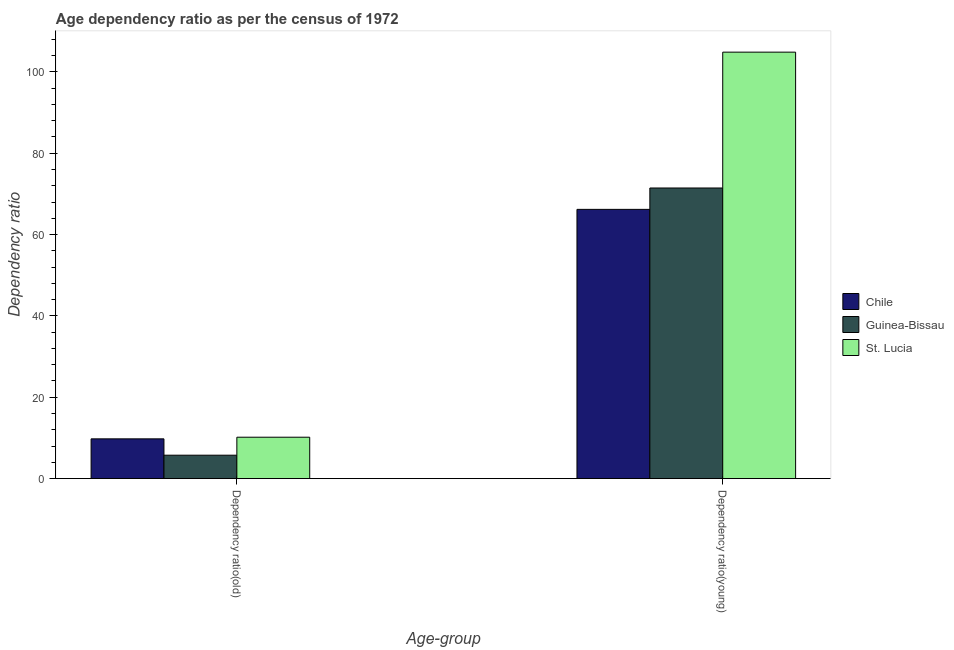How many different coloured bars are there?
Give a very brief answer. 3. How many bars are there on the 1st tick from the right?
Keep it short and to the point. 3. What is the label of the 1st group of bars from the left?
Ensure brevity in your answer.  Dependency ratio(old). What is the age dependency ratio(young) in Chile?
Provide a succinct answer. 66.2. Across all countries, what is the maximum age dependency ratio(old)?
Offer a terse response. 10.18. Across all countries, what is the minimum age dependency ratio(young)?
Provide a succinct answer. 66.2. In which country was the age dependency ratio(old) maximum?
Your response must be concise. St. Lucia. What is the total age dependency ratio(young) in the graph?
Give a very brief answer. 242.5. What is the difference between the age dependency ratio(old) in Chile and that in Guinea-Bissau?
Your answer should be compact. 4.02. What is the difference between the age dependency ratio(old) in Guinea-Bissau and the age dependency ratio(young) in St. Lucia?
Ensure brevity in your answer.  -99.1. What is the average age dependency ratio(young) per country?
Your answer should be very brief. 80.83. What is the difference between the age dependency ratio(young) and age dependency ratio(old) in Guinea-Bissau?
Provide a short and direct response. 65.7. In how many countries, is the age dependency ratio(young) greater than 68 ?
Offer a very short reply. 2. What is the ratio of the age dependency ratio(old) in St. Lucia to that in Chile?
Your response must be concise. 1.04. In how many countries, is the age dependency ratio(young) greater than the average age dependency ratio(young) taken over all countries?
Give a very brief answer. 1. What does the 3rd bar from the left in Dependency ratio(old) represents?
Make the answer very short. St. Lucia. What does the 2nd bar from the right in Dependency ratio(young) represents?
Provide a succinct answer. Guinea-Bissau. Are all the bars in the graph horizontal?
Give a very brief answer. No. What is the difference between two consecutive major ticks on the Y-axis?
Ensure brevity in your answer.  20. Are the values on the major ticks of Y-axis written in scientific E-notation?
Provide a succinct answer. No. Does the graph contain any zero values?
Ensure brevity in your answer.  No. Does the graph contain grids?
Offer a terse response. No. What is the title of the graph?
Your response must be concise. Age dependency ratio as per the census of 1972. Does "Liechtenstein" appear as one of the legend labels in the graph?
Your answer should be compact. No. What is the label or title of the X-axis?
Provide a short and direct response. Age-group. What is the label or title of the Y-axis?
Your answer should be very brief. Dependency ratio. What is the Dependency ratio in Chile in Dependency ratio(old)?
Your response must be concise. 9.78. What is the Dependency ratio in Guinea-Bissau in Dependency ratio(old)?
Keep it short and to the point. 5.76. What is the Dependency ratio in St. Lucia in Dependency ratio(old)?
Offer a terse response. 10.18. What is the Dependency ratio of Chile in Dependency ratio(young)?
Ensure brevity in your answer.  66.2. What is the Dependency ratio in Guinea-Bissau in Dependency ratio(young)?
Give a very brief answer. 71.45. What is the Dependency ratio of St. Lucia in Dependency ratio(young)?
Give a very brief answer. 104.85. Across all Age-group, what is the maximum Dependency ratio of Chile?
Your response must be concise. 66.2. Across all Age-group, what is the maximum Dependency ratio in Guinea-Bissau?
Offer a very short reply. 71.45. Across all Age-group, what is the maximum Dependency ratio in St. Lucia?
Give a very brief answer. 104.85. Across all Age-group, what is the minimum Dependency ratio in Chile?
Provide a short and direct response. 9.78. Across all Age-group, what is the minimum Dependency ratio of Guinea-Bissau?
Make the answer very short. 5.76. Across all Age-group, what is the minimum Dependency ratio of St. Lucia?
Provide a short and direct response. 10.18. What is the total Dependency ratio of Chile in the graph?
Your answer should be compact. 75.97. What is the total Dependency ratio in Guinea-Bissau in the graph?
Your answer should be compact. 77.21. What is the total Dependency ratio of St. Lucia in the graph?
Your response must be concise. 115.03. What is the difference between the Dependency ratio of Chile in Dependency ratio(old) and that in Dependency ratio(young)?
Offer a very short reply. -56.42. What is the difference between the Dependency ratio in Guinea-Bissau in Dependency ratio(old) and that in Dependency ratio(young)?
Your answer should be very brief. -65.7. What is the difference between the Dependency ratio of St. Lucia in Dependency ratio(old) and that in Dependency ratio(young)?
Provide a short and direct response. -94.67. What is the difference between the Dependency ratio in Chile in Dependency ratio(old) and the Dependency ratio in Guinea-Bissau in Dependency ratio(young)?
Offer a terse response. -61.68. What is the difference between the Dependency ratio in Chile in Dependency ratio(old) and the Dependency ratio in St. Lucia in Dependency ratio(young)?
Provide a short and direct response. -95.08. What is the difference between the Dependency ratio in Guinea-Bissau in Dependency ratio(old) and the Dependency ratio in St. Lucia in Dependency ratio(young)?
Offer a terse response. -99.1. What is the average Dependency ratio in Chile per Age-group?
Offer a very short reply. 37.99. What is the average Dependency ratio of Guinea-Bissau per Age-group?
Give a very brief answer. 38.6. What is the average Dependency ratio of St. Lucia per Age-group?
Provide a succinct answer. 57.52. What is the difference between the Dependency ratio of Chile and Dependency ratio of Guinea-Bissau in Dependency ratio(old)?
Give a very brief answer. 4.02. What is the difference between the Dependency ratio in Chile and Dependency ratio in St. Lucia in Dependency ratio(old)?
Offer a terse response. -0.4. What is the difference between the Dependency ratio of Guinea-Bissau and Dependency ratio of St. Lucia in Dependency ratio(old)?
Your answer should be compact. -4.42. What is the difference between the Dependency ratio of Chile and Dependency ratio of Guinea-Bissau in Dependency ratio(young)?
Provide a short and direct response. -5.25. What is the difference between the Dependency ratio of Chile and Dependency ratio of St. Lucia in Dependency ratio(young)?
Provide a succinct answer. -38.65. What is the difference between the Dependency ratio in Guinea-Bissau and Dependency ratio in St. Lucia in Dependency ratio(young)?
Provide a succinct answer. -33.4. What is the ratio of the Dependency ratio of Chile in Dependency ratio(old) to that in Dependency ratio(young)?
Keep it short and to the point. 0.15. What is the ratio of the Dependency ratio of Guinea-Bissau in Dependency ratio(old) to that in Dependency ratio(young)?
Your response must be concise. 0.08. What is the ratio of the Dependency ratio in St. Lucia in Dependency ratio(old) to that in Dependency ratio(young)?
Your response must be concise. 0.1. What is the difference between the highest and the second highest Dependency ratio in Chile?
Give a very brief answer. 56.42. What is the difference between the highest and the second highest Dependency ratio of Guinea-Bissau?
Provide a succinct answer. 65.7. What is the difference between the highest and the second highest Dependency ratio in St. Lucia?
Give a very brief answer. 94.67. What is the difference between the highest and the lowest Dependency ratio of Chile?
Give a very brief answer. 56.42. What is the difference between the highest and the lowest Dependency ratio of Guinea-Bissau?
Offer a very short reply. 65.7. What is the difference between the highest and the lowest Dependency ratio in St. Lucia?
Keep it short and to the point. 94.67. 